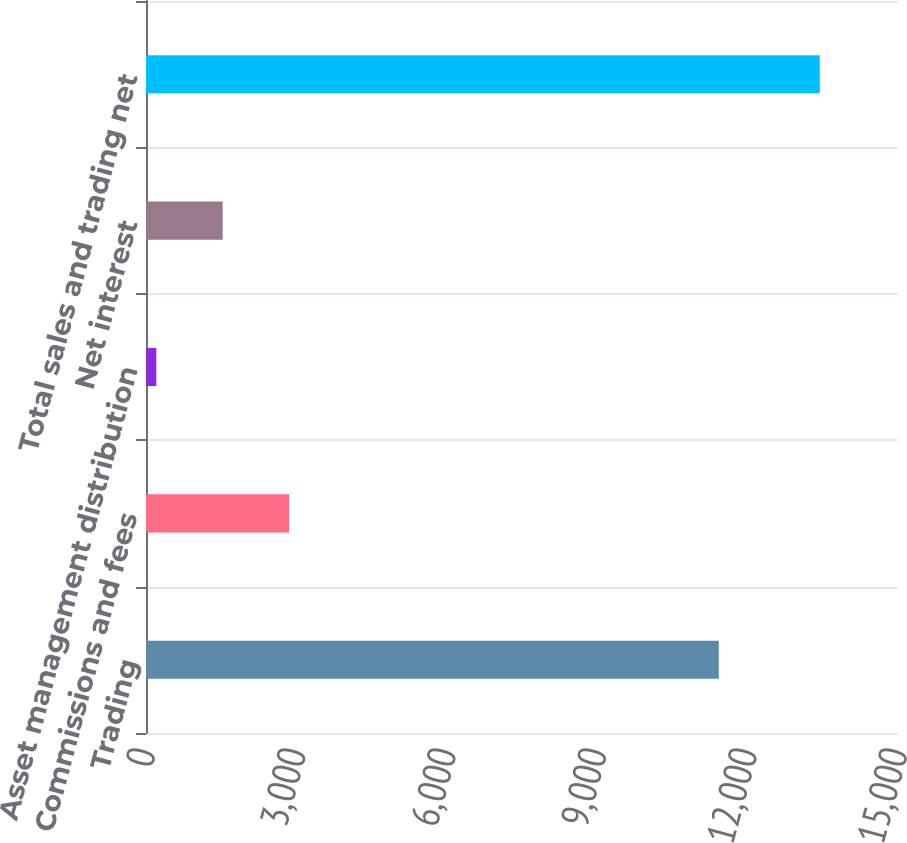Convert chart. <chart><loc_0><loc_0><loc_500><loc_500><bar_chart><fcel>Trading<fcel>Commissions and fees<fcel>Asset management distribution<fcel>Net interest<fcel>Total sales and trading net<nl><fcel>11425<fcel>2852.8<fcel>206<fcel>1529.4<fcel>13440<nl></chart> 